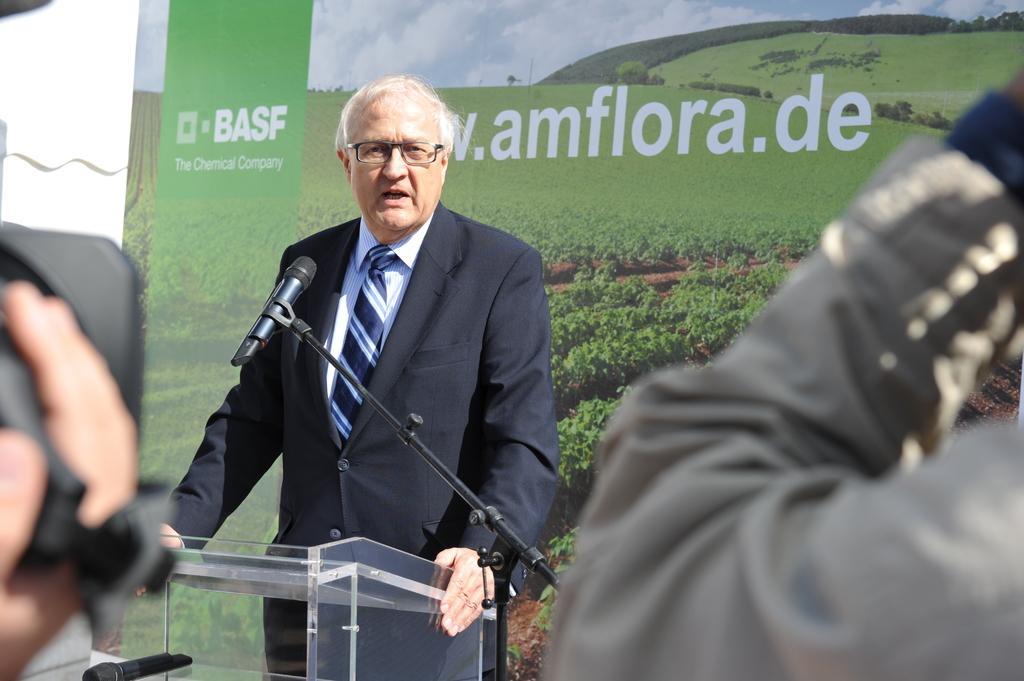In one or two sentences, can you explain what this image depicts? In this picture we can see few people, on the left side of the image we can see a camera, in the middle of the image we can find a man, in front of him we can see a podium and microphones, in the background we can see a hoarding. 